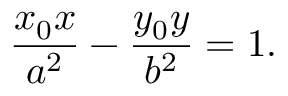<formula> <loc_0><loc_0><loc_500><loc_500>{ \frac { x _ { 0 } x } { a ^ { 2 } } } - { \frac { y _ { 0 } y } { b ^ { 2 } } } = 1 .</formula> 